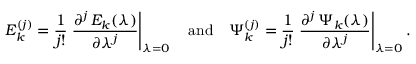<formula> <loc_0><loc_0><loc_500><loc_500>E _ { k } ^ { ( j ) } = \frac { 1 } { j ! } \frac { \partial ^ { j } \, E _ { k } ( \lambda ) } { \partial \lambda ^ { j } } \right | _ { \lambda = 0 } \quad a n d \quad \Psi _ { k } ^ { ( j ) } = \frac { 1 } { j ! } \frac { \partial ^ { j } \, \Psi _ { k } ( \lambda ) } { \partial \lambda ^ { j } } \right | _ { \lambda = 0 } .</formula> 